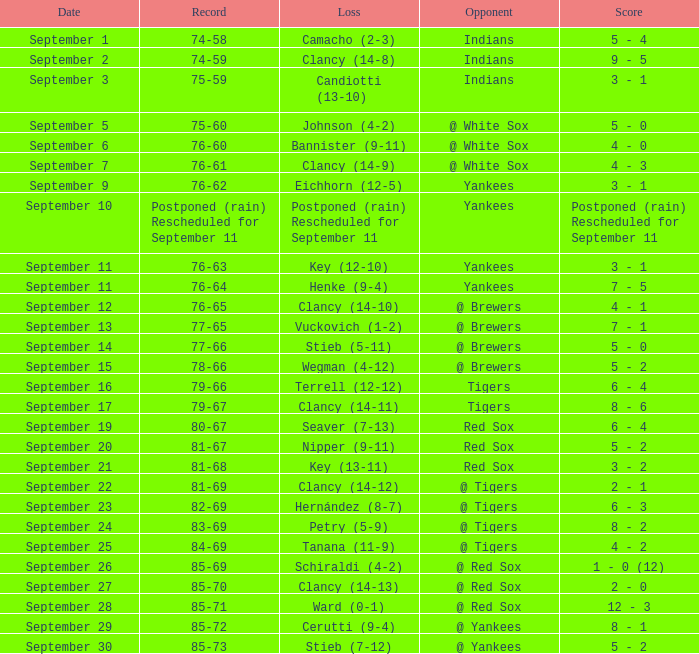Who was the Blue Jays opponent when their record was 84-69? @ Tigers. 